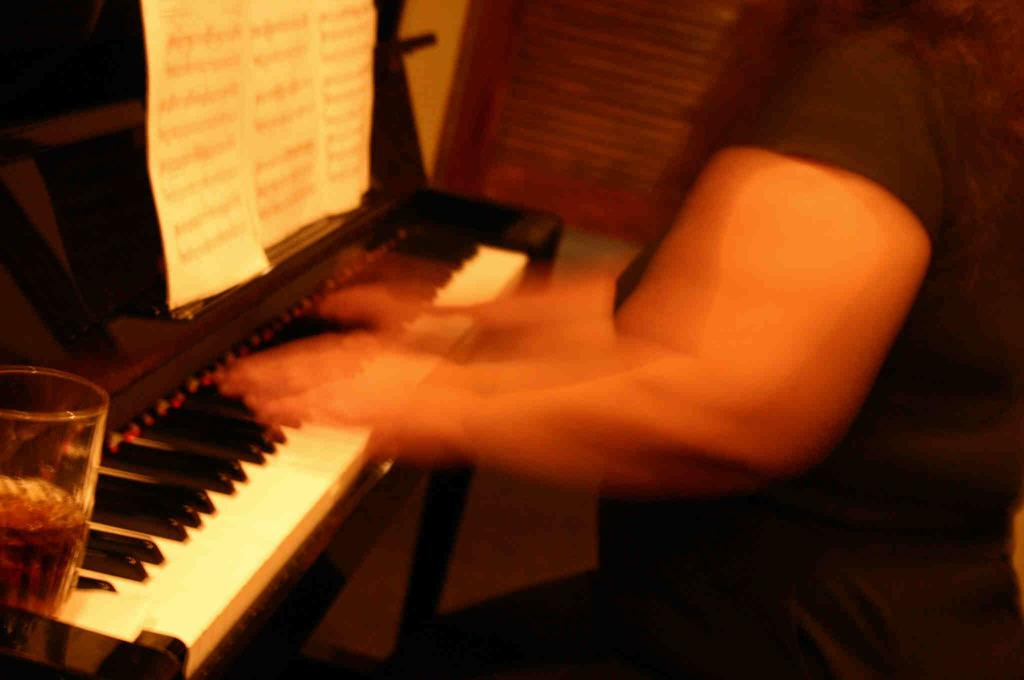What is the person in the image doing? The person in the image is playing the piano. What object is to the left of the person? There is a glass to the left of the person. What is placed in front of the person? There is a paper in front of the person. How many members are on the team in the image? There is no team present in the image; it features a person playing the piano. What type of bird can be seen perched on the piano in the image? There is no bird, specifically a wren, present in the image. 